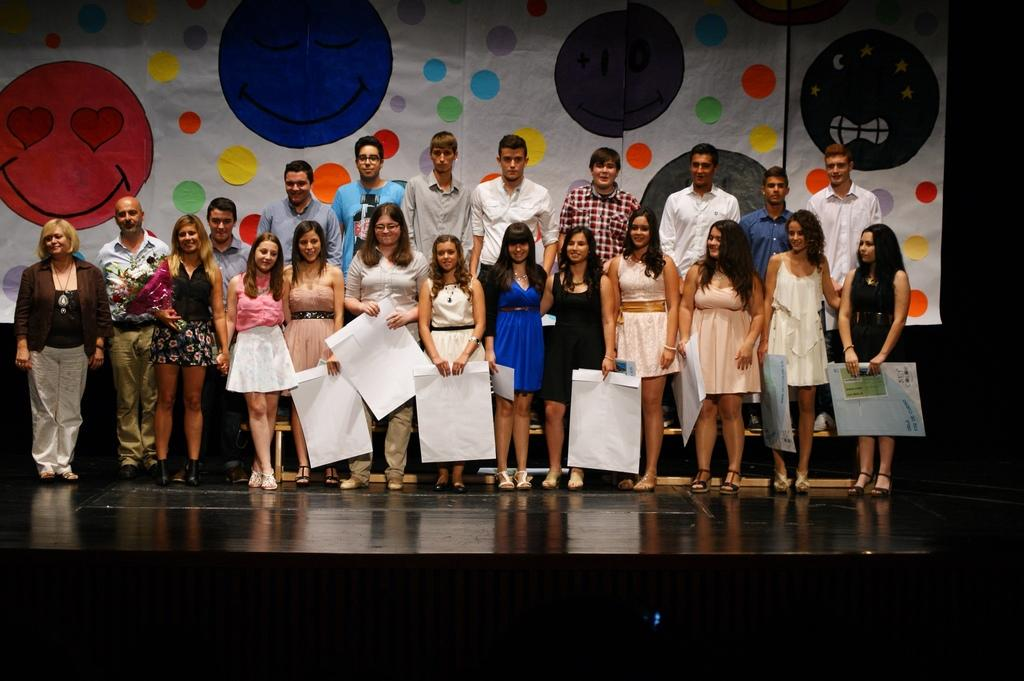How many people are in the image? There is a group of people in the image. What are the people in the image doing? The people are posing for a camera. What are some people holding in the image? Some people are holding papers. What is the woman holding in the image? The woman is holding a flower bouquet. What is visible beneath the people in the image? The image shows a floor. What can be seen in the background of the image? There is a banner in the background of the image. What type of destruction is being caused by the hammer in the image? There is no hammer present in the image, so no destruction can be observed. How many yams are visible in the image? There are no yams present in the image. 